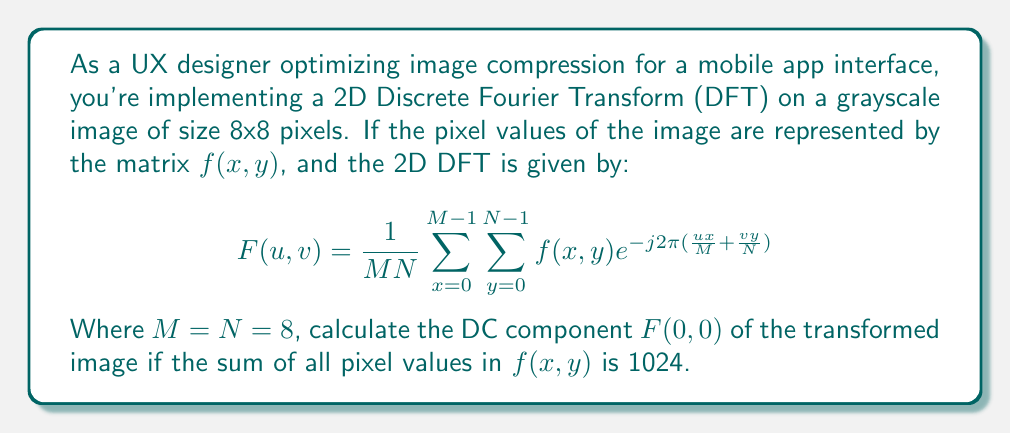Help me with this question. To solve this problem, let's break it down step by step:

1) The DC component $F(0,0)$ represents the average intensity of the image. It's calculated by setting $u=0$ and $v=0$ in the 2D DFT formula.

2) When $u=0$ and $v=0$, the exponential term becomes:

   $e^{-j2\pi(\frac{0x}{M} + \frac{0y}{N})} = e^0 = 1$

3) This simplifies our equation to:

   $$F(0,0) = \frac{1}{MN} \sum_{x=0}^{M-1} \sum_{y=0}^{N-1} f(x,y)$$

4) We're given that $M=N=8$, so $MN = 64$.

5) We're also told that the sum of all pixel values in $f(x,y)$ is 1024. This sum is exactly what's represented by the double summation in our simplified equation.

6) Substituting these values:

   $$F(0,0) = \frac{1}{64} \cdot 1024$$

7) Simplifying:

   $$F(0,0) = 16$$

This result makes sense in the context of image compression and UI design. The DC component represents the average intensity of the image, which is crucial for maintaining overall brightness when compressing images for faster loading in mobile interfaces.
Answer: $F(0,0) = 16$ 